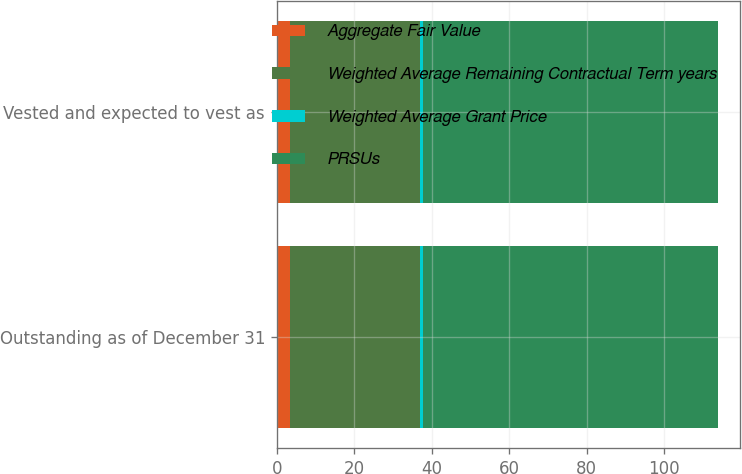<chart> <loc_0><loc_0><loc_500><loc_500><stacked_bar_chart><ecel><fcel>Outstanding as of December 31<fcel>Vested and expected to vest as<nl><fcel>Aggregate Fair Value<fcel>3.5<fcel>3.5<nl><fcel>Weighted Average Remaining Contractual Term years<fcel>33.41<fcel>33.41<nl><fcel>Weighted Average Grant Price<fcel>0.9<fcel>0.9<nl><fcel>PRSUs<fcel>76<fcel>76<nl></chart> 